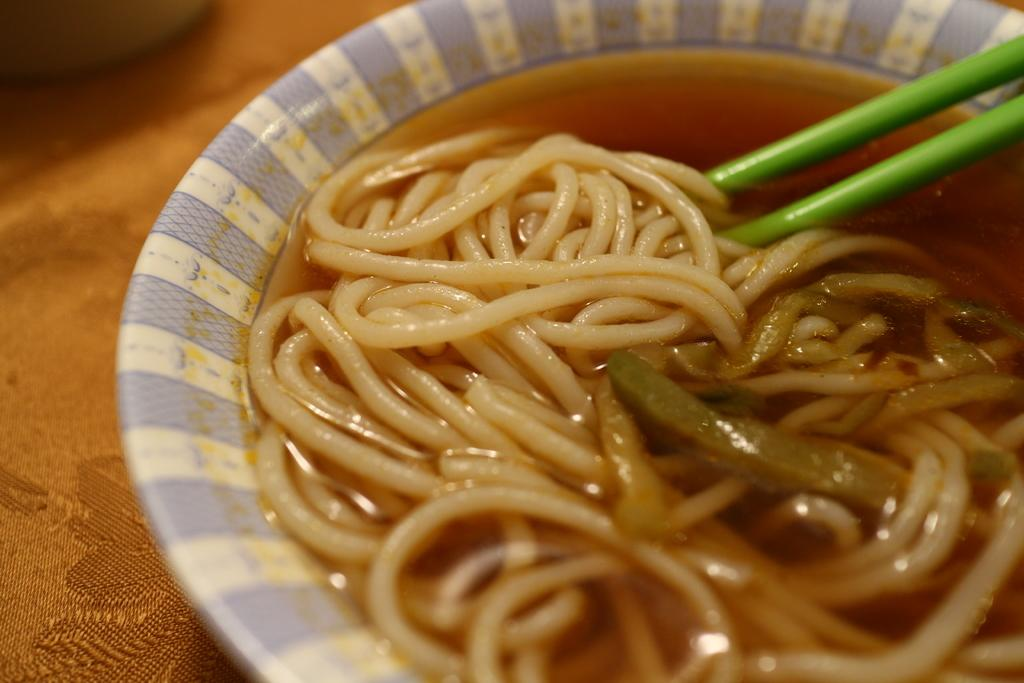What is in the bowl that is visible in the image? There is a bowl with noodles in it. What utensil is present with the bowl? There are chopsticks present. On what is the bowl placed? The bowl is placed on a table. What type of hope can be seen in the image? There is no reference to hope in the image; it features a bowl of noodles with chopsticks on a table. 